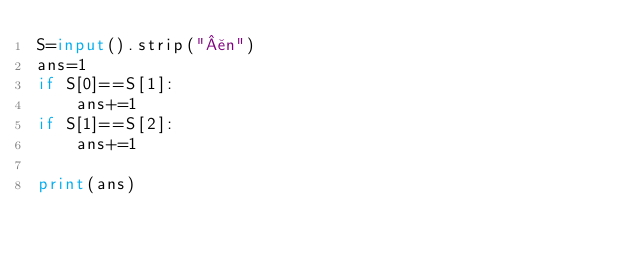Convert code to text. <code><loc_0><loc_0><loc_500><loc_500><_Python_>S=input().strip("¥n")
ans=1
if S[0]==S[1]:
	ans+=1
if S[1]==S[2]:
	ans+=1
	
print(ans)</code> 